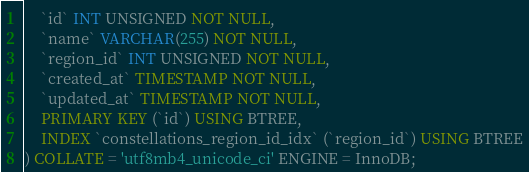Convert code to text. <code><loc_0><loc_0><loc_500><loc_500><_SQL_>    `id` INT UNSIGNED NOT NULL,
    `name` VARCHAR(255) NOT NULL,
    `region_id` INT UNSIGNED NOT NULL,
    `created_at` TIMESTAMP NOT NULL,
    `updated_at` TIMESTAMP NOT NULL,
    PRIMARY KEY (`id`) USING BTREE,
    INDEX `constellations_region_id_idx` (`region_id`) USING BTREE
) COLLATE = 'utf8mb4_unicode_ci' ENGINE = InnoDB;</code> 